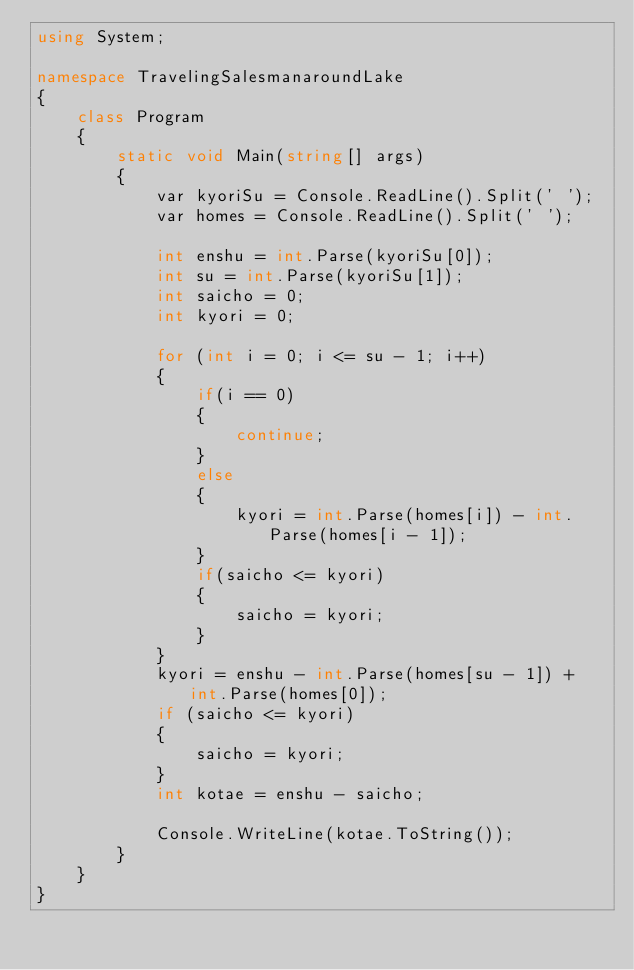Convert code to text. <code><loc_0><loc_0><loc_500><loc_500><_C#_>using System;

namespace TravelingSalesmanaroundLake
{
    class Program
    {
        static void Main(string[] args)
        {
            var kyoriSu = Console.ReadLine().Split(' ');
            var homes = Console.ReadLine().Split(' ');

            int enshu = int.Parse(kyoriSu[0]);
            int su = int.Parse(kyoriSu[1]);
            int saicho = 0;
            int kyori = 0;

            for (int i = 0; i <= su - 1; i++)
            {
                if(i == 0)
                {
                    continue;
                }
                else
                {
                    kyori = int.Parse(homes[i]) - int.Parse(homes[i - 1]);
                }
                if(saicho <= kyori)
                {
                    saicho = kyori;
                }
            }
            kyori = enshu - int.Parse(homes[su - 1]) + int.Parse(homes[0]);
            if (saicho <= kyori)
            {
                saicho = kyori;
            }
            int kotae = enshu - saicho;

            Console.WriteLine(kotae.ToString());
        }
    }
}</code> 